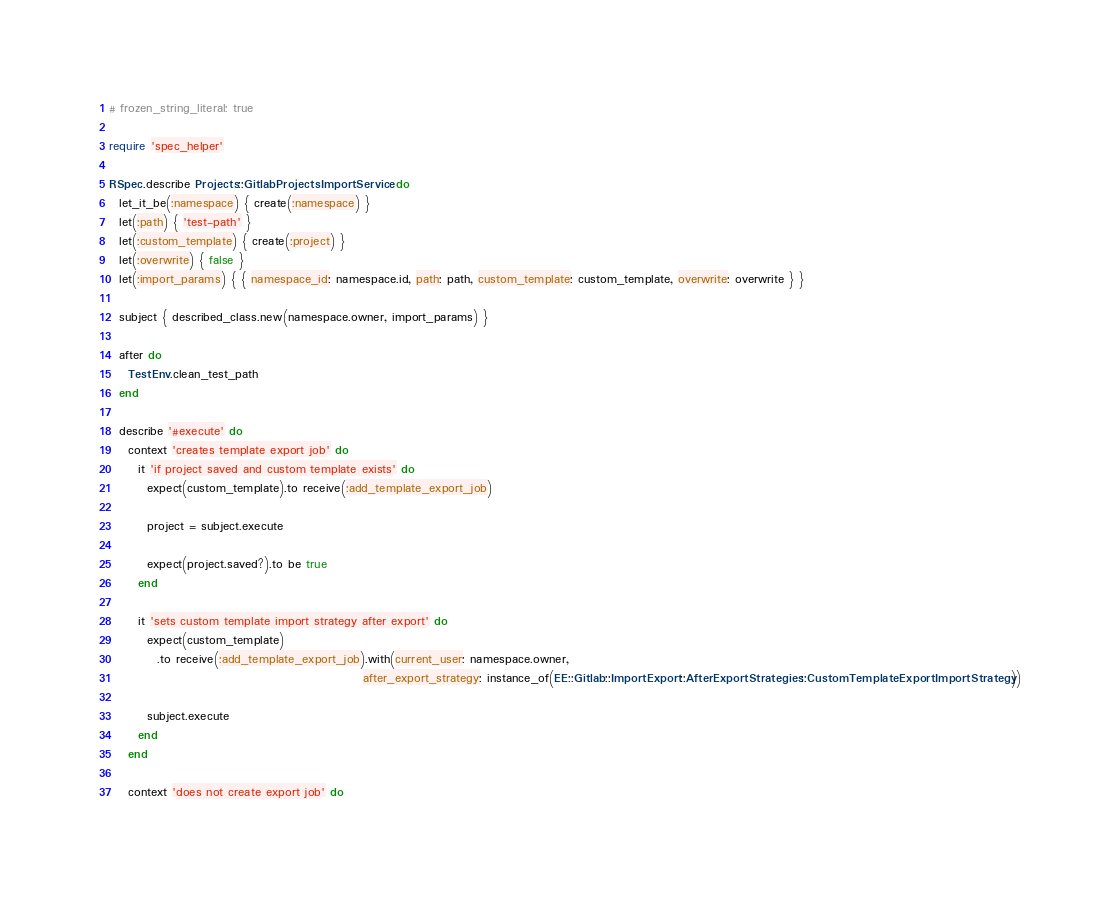<code> <loc_0><loc_0><loc_500><loc_500><_Ruby_># frozen_string_literal: true

require 'spec_helper'

RSpec.describe Projects::GitlabProjectsImportService do
  let_it_be(:namespace) { create(:namespace) }
  let(:path) { 'test-path' }
  let(:custom_template) { create(:project) }
  let(:overwrite) { false }
  let(:import_params) { { namespace_id: namespace.id, path: path, custom_template: custom_template, overwrite: overwrite } }

  subject { described_class.new(namespace.owner, import_params) }

  after do
    TestEnv.clean_test_path
  end

  describe '#execute' do
    context 'creates template export job' do
      it 'if project saved and custom template exists' do
        expect(custom_template).to receive(:add_template_export_job)

        project = subject.execute

        expect(project.saved?).to be true
      end

      it 'sets custom template import strategy after export' do
        expect(custom_template)
          .to receive(:add_template_export_job).with(current_user: namespace.owner,
                                                     after_export_strategy: instance_of(EE::Gitlab::ImportExport::AfterExportStrategies::CustomTemplateExportImportStrategy))

        subject.execute
      end
    end

    context 'does not create export job' do</code> 